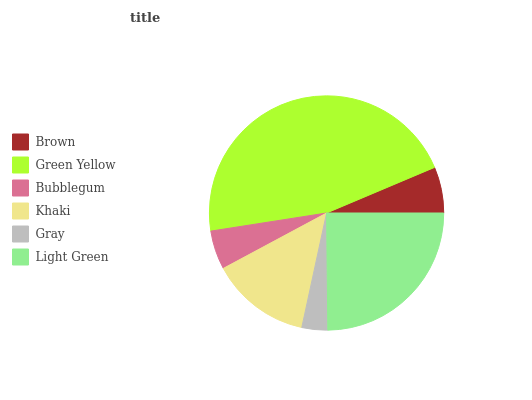Is Gray the minimum?
Answer yes or no. Yes. Is Green Yellow the maximum?
Answer yes or no. Yes. Is Bubblegum the minimum?
Answer yes or no. No. Is Bubblegum the maximum?
Answer yes or no. No. Is Green Yellow greater than Bubblegum?
Answer yes or no. Yes. Is Bubblegum less than Green Yellow?
Answer yes or no. Yes. Is Bubblegum greater than Green Yellow?
Answer yes or no. No. Is Green Yellow less than Bubblegum?
Answer yes or no. No. Is Khaki the high median?
Answer yes or no. Yes. Is Brown the low median?
Answer yes or no. Yes. Is Brown the high median?
Answer yes or no. No. Is Gray the low median?
Answer yes or no. No. 